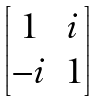Convert formula to latex. <formula><loc_0><loc_0><loc_500><loc_500>\begin{bmatrix} 1 & i \\ - i & 1 \end{bmatrix}</formula> 